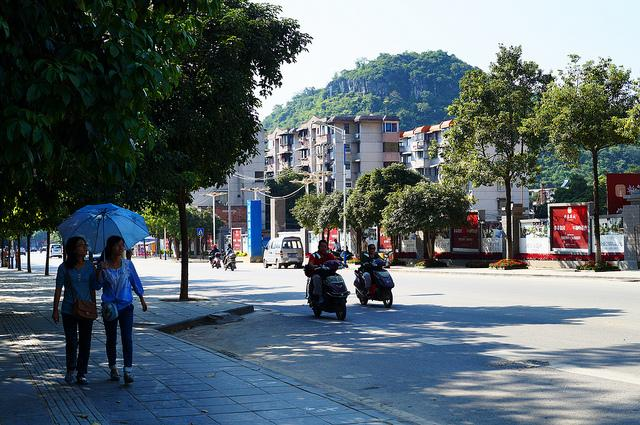What protection does an umbrella offer here? Please explain your reasoning. sun shade. It is not raining, and there are no locusts. umbrellas would not do much to stop nuclear fallout. 